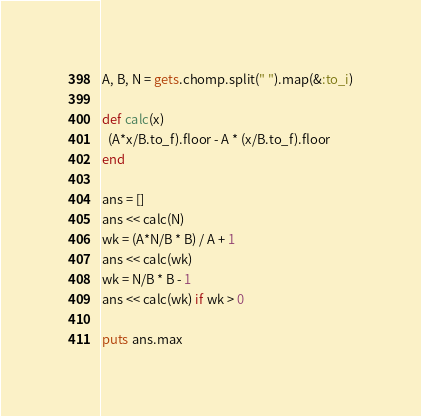<code> <loc_0><loc_0><loc_500><loc_500><_Ruby_>A, B, N = gets.chomp.split(" ").map(&:to_i)

def calc(x)
  (A*x/B.to_f).floor - A * (x/B.to_f).floor
end

ans = []
ans << calc(N)
wk = (A*N/B * B) / A + 1
ans << calc(wk)
wk = N/B * B - 1
ans << calc(wk) if wk > 0

puts ans.max
</code> 